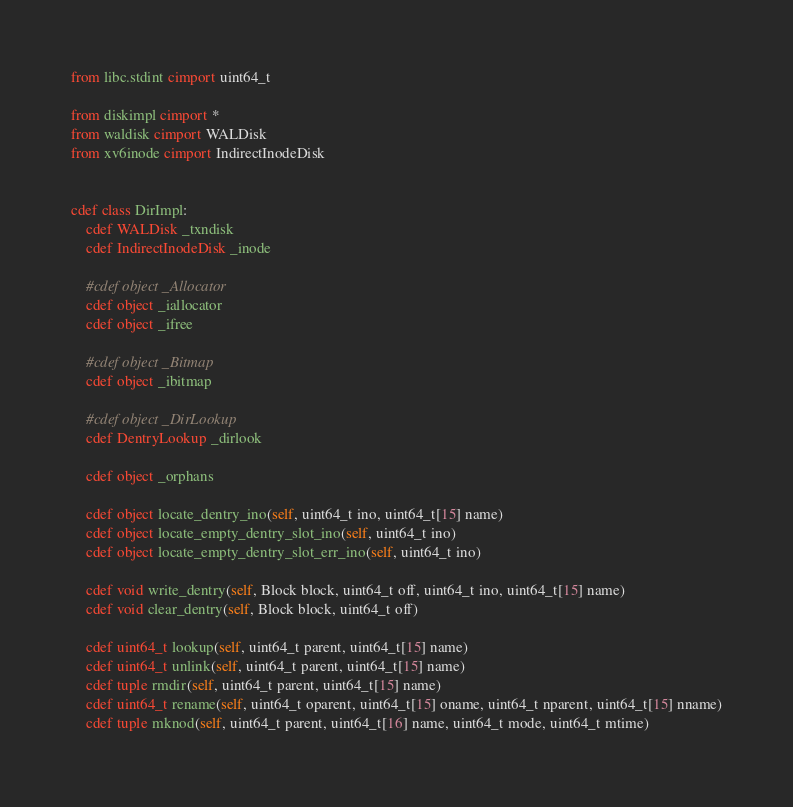<code> <loc_0><loc_0><loc_500><loc_500><_Cython_>from libc.stdint cimport uint64_t

from diskimpl cimport *
from waldisk cimport WALDisk
from xv6inode cimport IndirectInodeDisk


cdef class DirImpl:
    cdef WALDisk _txndisk
    cdef IndirectInodeDisk _inode

    #cdef object _Allocator
    cdef object _iallocator
    cdef object _ifree

    #cdef object _Bitmap
    cdef object _ibitmap

    #cdef object _DirLookup
    cdef DentryLookup _dirlook

    cdef object _orphans

    cdef object locate_dentry_ino(self, uint64_t ino, uint64_t[15] name)
    cdef object locate_empty_dentry_slot_ino(self, uint64_t ino)
    cdef object locate_empty_dentry_slot_err_ino(self, uint64_t ino)

    cdef void write_dentry(self, Block block, uint64_t off, uint64_t ino, uint64_t[15] name)
    cdef void clear_dentry(self, Block block, uint64_t off)

    cdef uint64_t lookup(self, uint64_t parent, uint64_t[15] name)
    cdef uint64_t unlink(self, uint64_t parent, uint64_t[15] name)
    cdef tuple rmdir(self, uint64_t parent, uint64_t[15] name)
    cdef uint64_t rename(self, uint64_t oparent, uint64_t[15] oname, uint64_t nparent, uint64_t[15] nname)
    cdef tuple mknod(self, uint64_t parent, uint64_t[16] name, uint64_t mode, uint64_t mtime)
</code> 